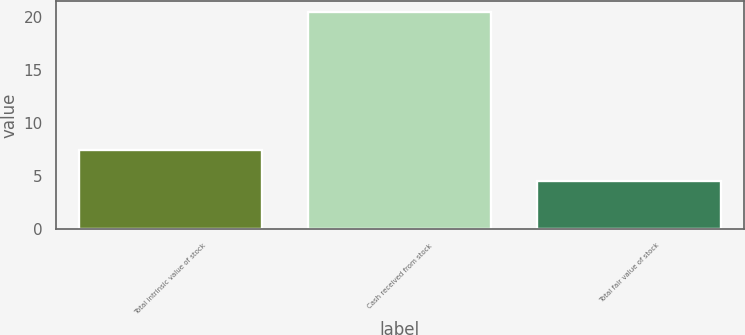Convert chart to OTSL. <chart><loc_0><loc_0><loc_500><loc_500><bar_chart><fcel>Total intrinsic value of stock<fcel>Cash received from stock<fcel>Total fair value of stock<nl><fcel>7.5<fcel>20.5<fcel>4.5<nl></chart> 